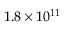<formula> <loc_0><loc_0><loc_500><loc_500>1 . 8 \times 1 0 ^ { 1 1 }</formula> 